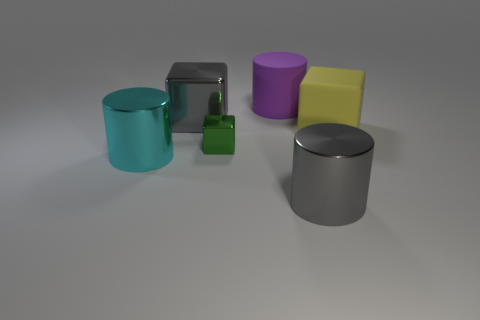There is a green thing that is the same material as the big cyan object; what is its size?
Keep it short and to the point. Small. Are the purple cylinder and the big block in front of the gray metal cube made of the same material?
Offer a terse response. Yes. There is a gray thing that is the same shape as the small green thing; what material is it?
Provide a short and direct response. Metal. Are the big gray thing that is left of the large rubber cylinder and the cylinder that is to the left of the big purple cylinder made of the same material?
Ensure brevity in your answer.  Yes. What number of other things are the same shape as the yellow rubber thing?
Offer a very short reply. 2. Is the material of the large cyan cylinder the same as the gray cylinder?
Keep it short and to the point. Yes. Do the large object that is in front of the large cyan thing and the large metallic cube have the same color?
Ensure brevity in your answer.  Yes. What is the shape of the large gray shiny object in front of the large gray metal cube?
Provide a succinct answer. Cylinder. There is a cylinder behind the large cyan object; is there a tiny green metal thing that is on the right side of it?
Give a very brief answer. No. What number of big brown spheres are made of the same material as the large cyan object?
Your response must be concise. 0. 